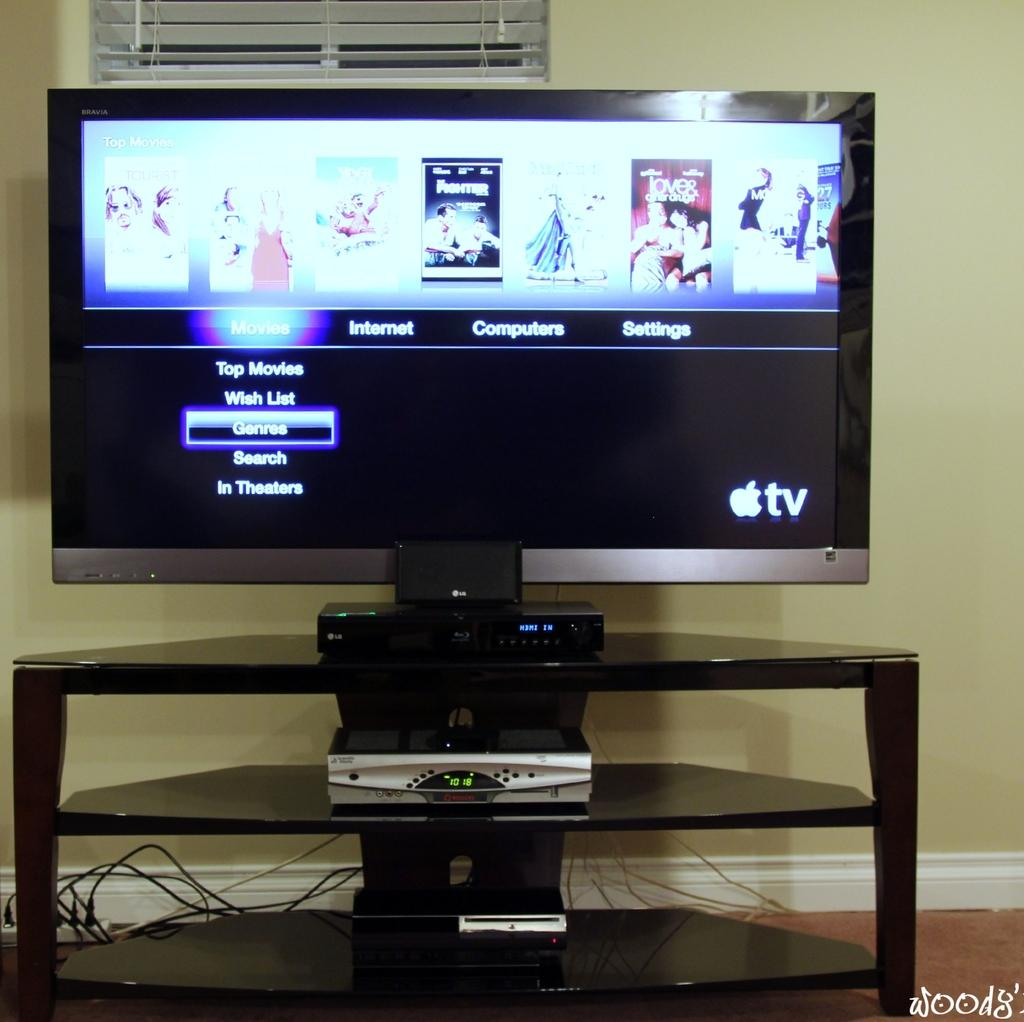<image>
Create a compact narrative representing the image presented. The visual menu of an Apple tv has the cursor on genres. 